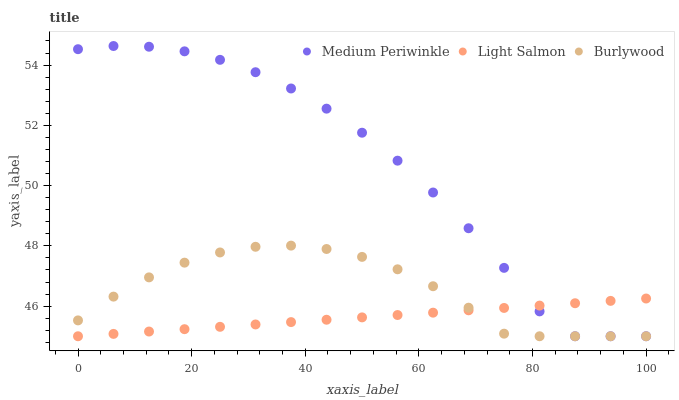Does Light Salmon have the minimum area under the curve?
Answer yes or no. Yes. Does Medium Periwinkle have the maximum area under the curve?
Answer yes or no. Yes. Does Medium Periwinkle have the minimum area under the curve?
Answer yes or no. No. Does Light Salmon have the maximum area under the curve?
Answer yes or no. No. Is Light Salmon the smoothest?
Answer yes or no. Yes. Is Medium Periwinkle the roughest?
Answer yes or no. Yes. Is Medium Periwinkle the smoothest?
Answer yes or no. No. Is Light Salmon the roughest?
Answer yes or no. No. Does Burlywood have the lowest value?
Answer yes or no. Yes. Does Medium Periwinkle have the highest value?
Answer yes or no. Yes. Does Light Salmon have the highest value?
Answer yes or no. No. Does Medium Periwinkle intersect Burlywood?
Answer yes or no. Yes. Is Medium Periwinkle less than Burlywood?
Answer yes or no. No. Is Medium Periwinkle greater than Burlywood?
Answer yes or no. No. 